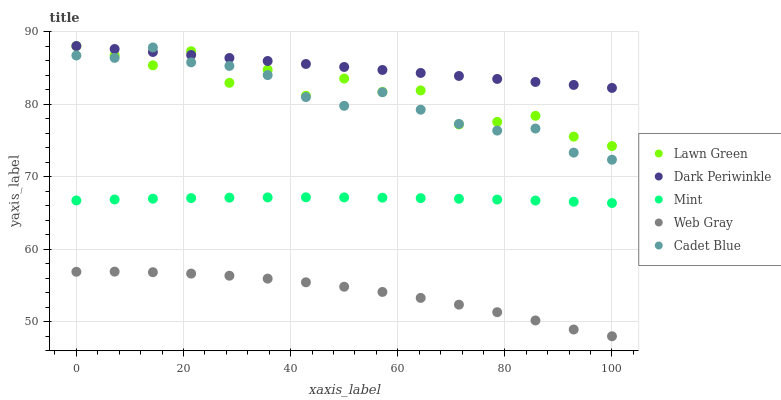Does Web Gray have the minimum area under the curve?
Answer yes or no. Yes. Does Dark Periwinkle have the maximum area under the curve?
Answer yes or no. Yes. Does Lawn Green have the minimum area under the curve?
Answer yes or no. No. Does Lawn Green have the maximum area under the curve?
Answer yes or no. No. Is Dark Periwinkle the smoothest?
Answer yes or no. Yes. Is Lawn Green the roughest?
Answer yes or no. Yes. Is Web Gray the smoothest?
Answer yes or no. No. Is Web Gray the roughest?
Answer yes or no. No. Does Web Gray have the lowest value?
Answer yes or no. Yes. Does Lawn Green have the lowest value?
Answer yes or no. No. Does Dark Periwinkle have the highest value?
Answer yes or no. Yes. Does Web Gray have the highest value?
Answer yes or no. No. Is Web Gray less than Mint?
Answer yes or no. Yes. Is Mint greater than Web Gray?
Answer yes or no. Yes. Does Cadet Blue intersect Dark Periwinkle?
Answer yes or no. Yes. Is Cadet Blue less than Dark Periwinkle?
Answer yes or no. No. Is Cadet Blue greater than Dark Periwinkle?
Answer yes or no. No. Does Web Gray intersect Mint?
Answer yes or no. No. 